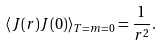<formula> <loc_0><loc_0><loc_500><loc_500>\left \langle J ( r ) J ( 0 ) \right \rangle _ { T = m = 0 } = \frac { 1 } { r ^ { 2 } } .</formula> 